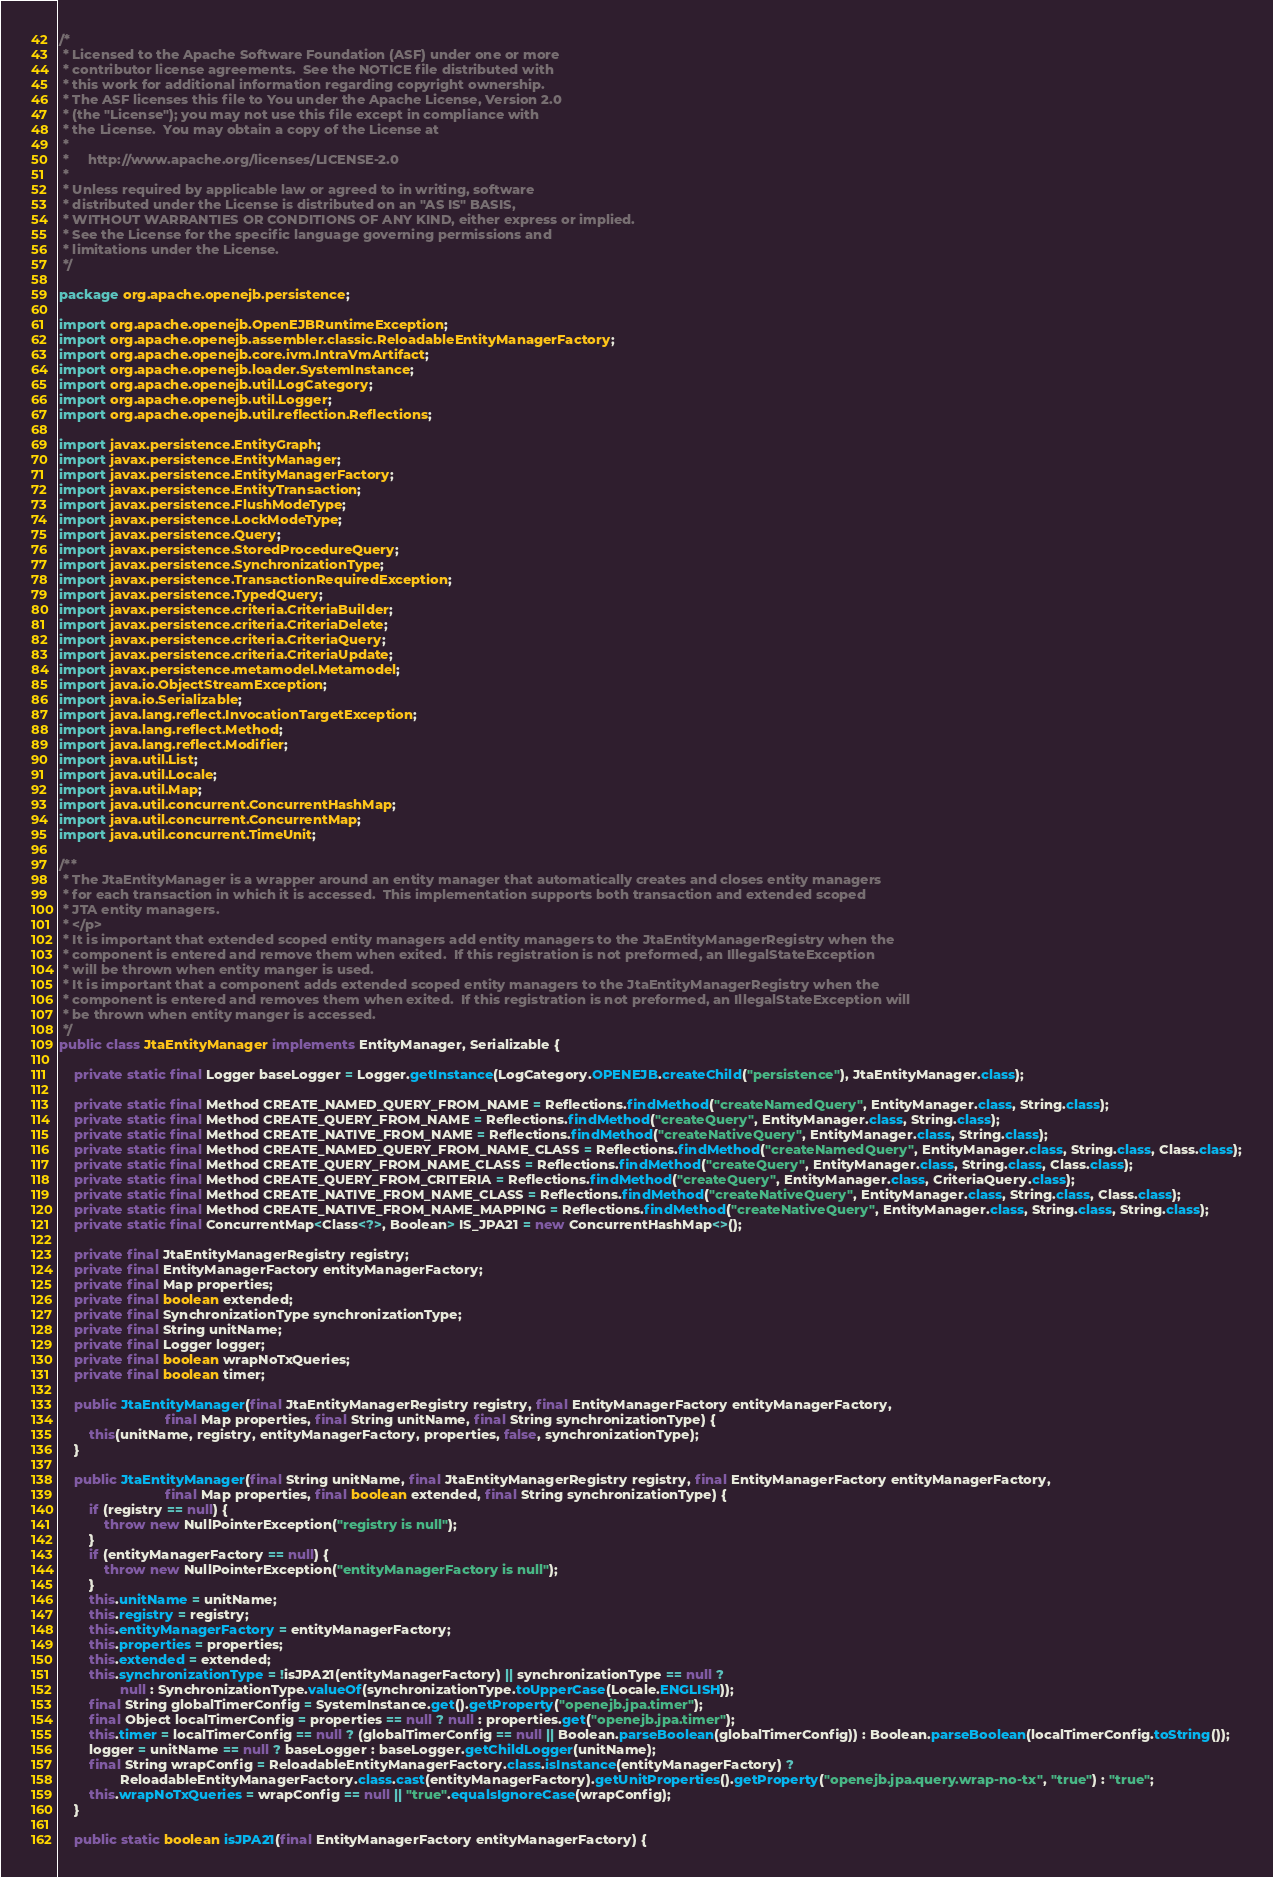Convert code to text. <code><loc_0><loc_0><loc_500><loc_500><_Java_>/*
 * Licensed to the Apache Software Foundation (ASF) under one or more
 * contributor license agreements.  See the NOTICE file distributed with
 * this work for additional information regarding copyright ownership.
 * The ASF licenses this file to You under the Apache License, Version 2.0
 * (the "License"); you may not use this file except in compliance with
 * the License.  You may obtain a copy of the License at
 *
 *     http://www.apache.org/licenses/LICENSE-2.0
 *
 * Unless required by applicable law or agreed to in writing, software
 * distributed under the License is distributed on an "AS IS" BASIS,
 * WITHOUT WARRANTIES OR CONDITIONS OF ANY KIND, either express or implied.
 * See the License for the specific language governing permissions and
 * limitations under the License.
 */

package org.apache.openejb.persistence;

import org.apache.openejb.OpenEJBRuntimeException;
import org.apache.openejb.assembler.classic.ReloadableEntityManagerFactory;
import org.apache.openejb.core.ivm.IntraVmArtifact;
import org.apache.openejb.loader.SystemInstance;
import org.apache.openejb.util.LogCategory;
import org.apache.openejb.util.Logger;
import org.apache.openejb.util.reflection.Reflections;

import javax.persistence.EntityGraph;
import javax.persistence.EntityManager;
import javax.persistence.EntityManagerFactory;
import javax.persistence.EntityTransaction;
import javax.persistence.FlushModeType;
import javax.persistence.LockModeType;
import javax.persistence.Query;
import javax.persistence.StoredProcedureQuery;
import javax.persistence.SynchronizationType;
import javax.persistence.TransactionRequiredException;
import javax.persistence.TypedQuery;
import javax.persistence.criteria.CriteriaBuilder;
import javax.persistence.criteria.CriteriaDelete;
import javax.persistence.criteria.CriteriaQuery;
import javax.persistence.criteria.CriteriaUpdate;
import javax.persistence.metamodel.Metamodel;
import java.io.ObjectStreamException;
import java.io.Serializable;
import java.lang.reflect.InvocationTargetException;
import java.lang.reflect.Method;
import java.lang.reflect.Modifier;
import java.util.List;
import java.util.Locale;
import java.util.Map;
import java.util.concurrent.ConcurrentHashMap;
import java.util.concurrent.ConcurrentMap;
import java.util.concurrent.TimeUnit;

/**
 * The JtaEntityManager is a wrapper around an entity manager that automatically creates and closes entity managers
 * for each transaction in which it is accessed.  This implementation supports both transaction and extended scoped
 * JTA entity managers.
 * </p>
 * It is important that extended scoped entity managers add entity managers to the JtaEntityManagerRegistry when the
 * component is entered and remove them when exited.  If this registration is not preformed, an IllegalStateException
 * will be thrown when entity manger is used.
 * It is important that a component adds extended scoped entity managers to the JtaEntityManagerRegistry when the
 * component is entered and removes them when exited.  If this registration is not preformed, an IllegalStateException will
 * be thrown when entity manger is accessed.
 */
public class JtaEntityManager implements EntityManager, Serializable {

    private static final Logger baseLogger = Logger.getInstance(LogCategory.OPENEJB.createChild("persistence"), JtaEntityManager.class);

    private static final Method CREATE_NAMED_QUERY_FROM_NAME = Reflections.findMethod("createNamedQuery", EntityManager.class, String.class);
    private static final Method CREATE_QUERY_FROM_NAME = Reflections.findMethod("createQuery", EntityManager.class, String.class);
    private static final Method CREATE_NATIVE_FROM_NAME = Reflections.findMethod("createNativeQuery", EntityManager.class, String.class);
    private static final Method CREATE_NAMED_QUERY_FROM_NAME_CLASS = Reflections.findMethod("createNamedQuery", EntityManager.class, String.class, Class.class);
    private static final Method CREATE_QUERY_FROM_NAME_CLASS = Reflections.findMethod("createQuery", EntityManager.class, String.class, Class.class);
    private static final Method CREATE_QUERY_FROM_CRITERIA = Reflections.findMethod("createQuery", EntityManager.class, CriteriaQuery.class);
    private static final Method CREATE_NATIVE_FROM_NAME_CLASS = Reflections.findMethod("createNativeQuery", EntityManager.class, String.class, Class.class);
    private static final Method CREATE_NATIVE_FROM_NAME_MAPPING = Reflections.findMethod("createNativeQuery", EntityManager.class, String.class, String.class);
    private static final ConcurrentMap<Class<?>, Boolean> IS_JPA21 = new ConcurrentHashMap<>();

    private final JtaEntityManagerRegistry registry;
    private final EntityManagerFactory entityManagerFactory;
    private final Map properties;
    private final boolean extended;
    private final SynchronizationType synchronizationType;
    private final String unitName;
    private final Logger logger;
    private final boolean wrapNoTxQueries;
    private final boolean timer;

    public JtaEntityManager(final JtaEntityManagerRegistry registry, final EntityManagerFactory entityManagerFactory,
                            final Map properties, final String unitName, final String synchronizationType) {
        this(unitName, registry, entityManagerFactory, properties, false, synchronizationType);
    }

    public JtaEntityManager(final String unitName, final JtaEntityManagerRegistry registry, final EntityManagerFactory entityManagerFactory,
                            final Map properties, final boolean extended, final String synchronizationType) {
        if (registry == null) {
            throw new NullPointerException("registry is null");
        }
        if (entityManagerFactory == null) {
            throw new NullPointerException("entityManagerFactory is null");
        }
        this.unitName = unitName;
        this.registry = registry;
        this.entityManagerFactory = entityManagerFactory;
        this.properties = properties;
        this.extended = extended;
        this.synchronizationType = !isJPA21(entityManagerFactory) || synchronizationType == null ?
                null : SynchronizationType.valueOf(synchronizationType.toUpperCase(Locale.ENGLISH));
        final String globalTimerConfig = SystemInstance.get().getProperty("openejb.jpa.timer");
        final Object localTimerConfig = properties == null ? null : properties.get("openejb.jpa.timer");
        this.timer = localTimerConfig == null ? (globalTimerConfig == null || Boolean.parseBoolean(globalTimerConfig)) : Boolean.parseBoolean(localTimerConfig.toString());
        logger = unitName == null ? baseLogger : baseLogger.getChildLogger(unitName);
        final String wrapConfig = ReloadableEntityManagerFactory.class.isInstance(entityManagerFactory) ?
                ReloadableEntityManagerFactory.class.cast(entityManagerFactory).getUnitProperties().getProperty("openejb.jpa.query.wrap-no-tx", "true") : "true";
        this.wrapNoTxQueries = wrapConfig == null || "true".equalsIgnoreCase(wrapConfig);
    }

    public static boolean isJPA21(final EntityManagerFactory entityManagerFactory) {</code> 